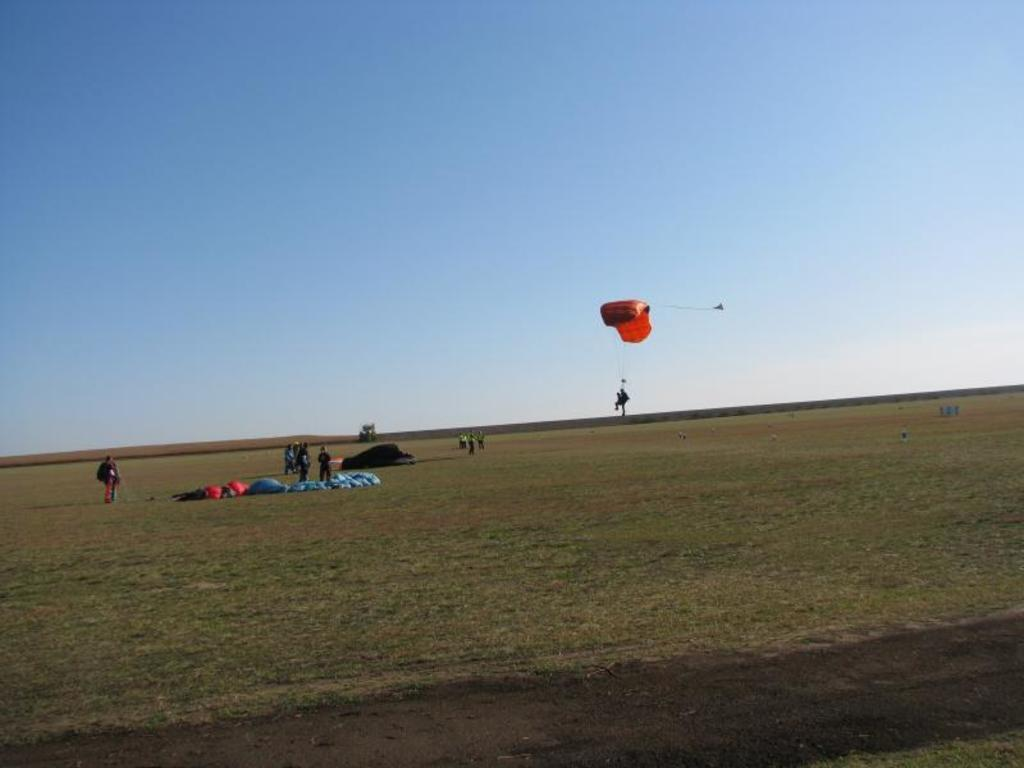What type of landscape is shown in the image? There is an open land in the image. Are there any people present in the image? Yes, there are people standing in the image. What can be seen in the sky in the background of the image? The sky is visible in the background of the image. What is the purpose of the parachute in the image? The parachute is visible in the image, but its purpose cannot be determined without additional context. What type of coal is being used to form the parachute in the image? There is no coal present in the image, and the parachute is not made of coal. 